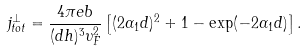Convert formula to latex. <formula><loc_0><loc_0><loc_500><loc_500>j ^ { \perp } _ { t o t } = \frac { 4 \pi e b } { ( d h ) ^ { 3 } \upsilon _ { F } ^ { 2 } } \left [ ( 2 \alpha _ { 1 } d ) ^ { 2 } + 1 - \exp ( - 2 \alpha _ { 1 } d ) \right ] .</formula> 